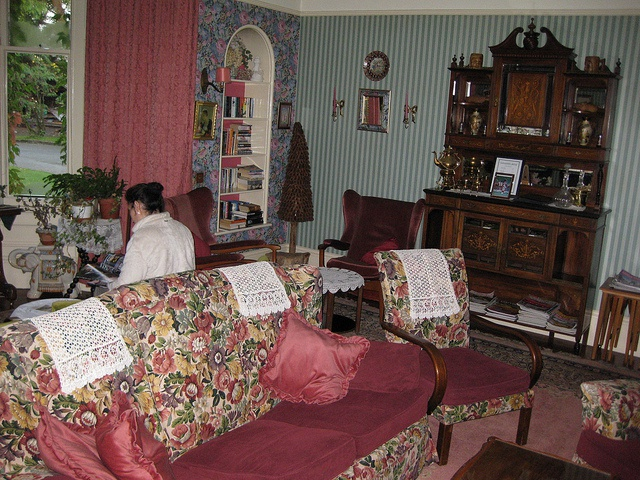Describe the objects in this image and their specific colors. I can see couch in gray, maroon, brown, and lightgray tones, chair in gray, maroon, black, and darkgray tones, chair in gray, black, maroon, and darkgray tones, people in gray, darkgray, lightgray, and black tones, and couch in gray, black, and maroon tones in this image. 